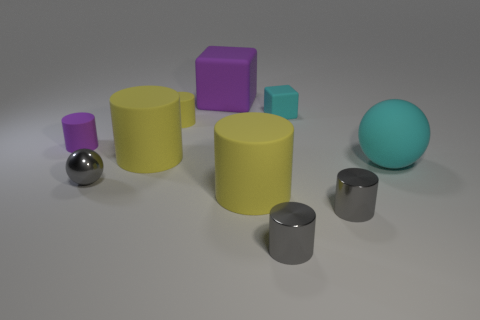How many balls are the same color as the big matte block?
Make the answer very short. 0. What number of cylinders are yellow matte objects or matte objects?
Make the answer very short. 4. There is a object that is right of the tiny block and in front of the big cyan ball; what is its shape?
Your answer should be very brief. Cylinder. Are there any purple rubber things that have the same size as the gray ball?
Your answer should be compact. Yes. How many objects are either tiny metal cylinders in front of the big cyan sphere or gray metal things?
Provide a succinct answer. 3. Do the tiny cyan object and the gray cylinder left of the small cyan matte thing have the same material?
Provide a short and direct response. No. How many other things are there of the same shape as the small cyan object?
Your response must be concise. 1. How many objects are either small matte cylinders behind the small gray metal ball or big purple things that are on the right side of the small gray ball?
Offer a terse response. 3. What number of other objects are there of the same color as the large ball?
Provide a succinct answer. 1. Are there fewer small cyan cubes that are in front of the tiny sphere than cyan matte balls that are to the left of the big rubber sphere?
Provide a short and direct response. No. 